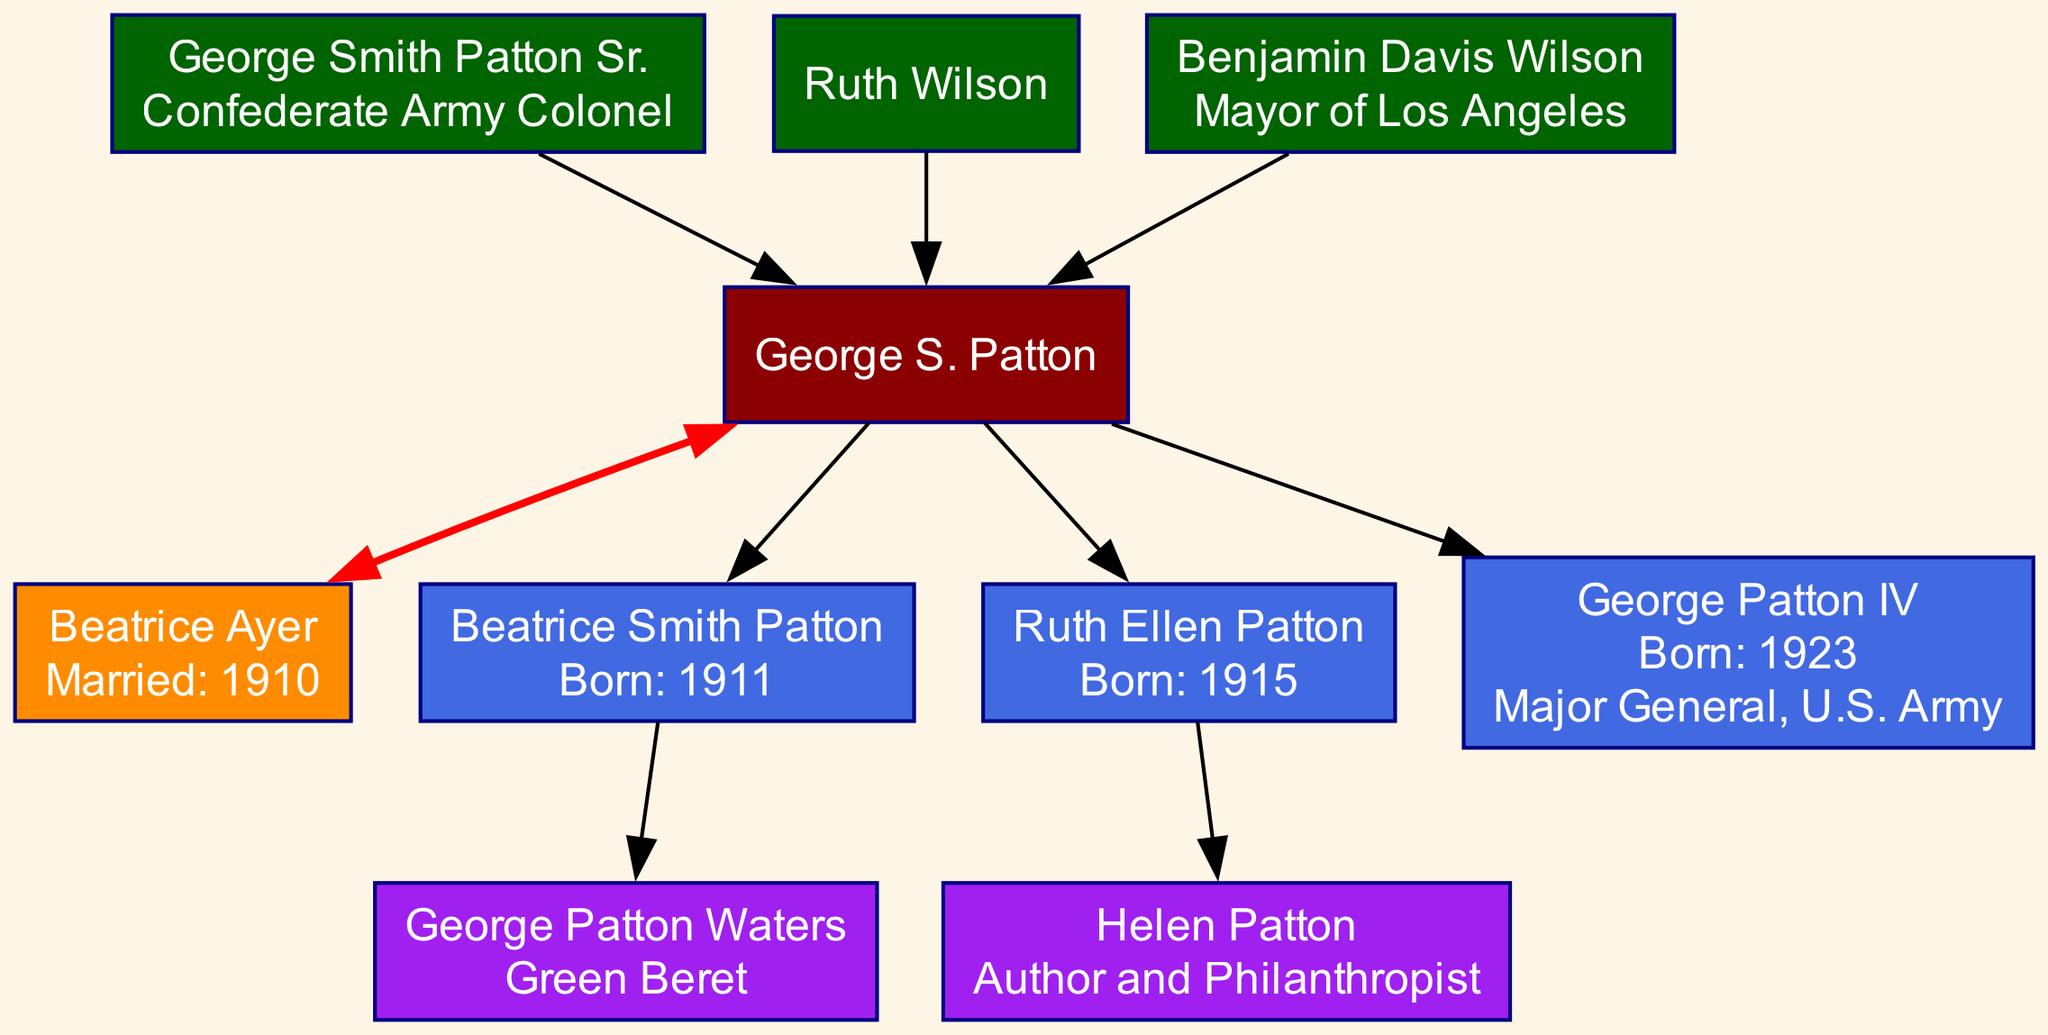What was the occupation of George Smith Patton Sr.? The diagram includes an information box for George Smith Patton Sr., which states he was a "Confederate Army Colonel." This clear occupation label allows us to answer the question directly.
Answer: Confederate Army Colonel How many children did George S. Patton have? The diagram lists the names of three children: Beatrice Smith Patton, Ruth Ellen Patton, and George Patton IV. Counting these entries gives the total number of children George S. Patton had.
Answer: 3 What is the birth year of George Patton IV? The diagram provides the birth year of George Patton IV in his node, specifically stating "Born: 1923." This direct information allows us to answer the question accurately.
Answer: 1923 Who is the maternal grandfather of George S. Patton? The diagram specifies that George S. Patton's maternal grandfather is Benjamin Davis Wilson. This relationship is directly connected in the diagram and can be identified by following the maternal lineage.
Answer: Benjamin Davis Wilson What occupation did Helen Patton have? The diagram indicates that Helen Patton is described as an "Author and Philanthropist." This occupation label is provided directly in her node, allowing for a straightforward answer.
Answer: Author and Philanthropist Who was George S. Patton's spouse? The diagram shows George S. Patton’s spouse listed as Beatrice Ayer, along with the marriage year. This information is displayed in the node associated with the spouse, providing a direct answer.
Answer: Beatrice Ayer Which of George S. Patton's children was a Major General in the U.S. Army? The diagram explicitly shows that George Patton IV is labeled as "Major General, U.S. Army." By identifying the relevant child node and checking the associated occupation, we can answer the question.
Answer: George Patton IV How many grandchildren did George S. Patton have? The diagram identifies two grandchildren: George Patton Waters and Helen Patton. By counting these names presented in the grandchildren section, we determine the total number of grandchildren.
Answer: 2 What year did George S. Patton marry Beatrice Ayer? The diagram states that George S. Patton was married to Beatrice Ayer in the year 1910. This information is included directly in the spouse's node and easily accessible.
Answer: 1910 